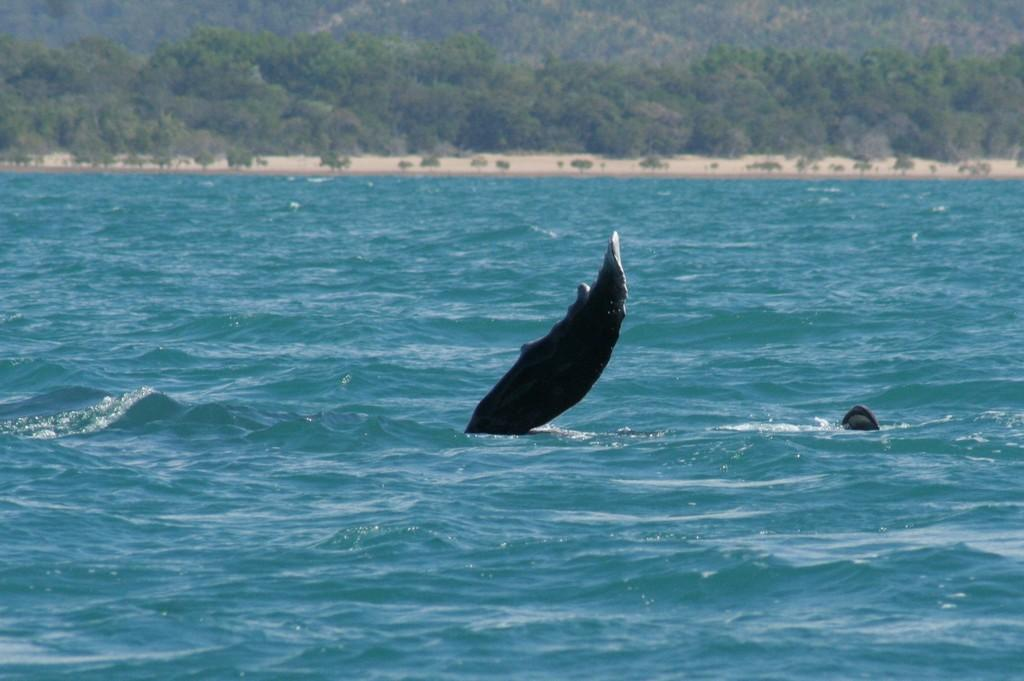What type of animal is in the image? There is an aquatic animal in the image. Where is the aquatic animal located? The aquatic animal is in the water. What can be seen in the background of the image? There are trees visible in the background of the image. What type of stamp can be seen on the aquatic animal in the image? There is no stamp present on the aquatic animal in the image. Is there a locket hanging around the neck of the aquatic animal in the image? There is no locket present around the neck of the aquatic animal in the image. 